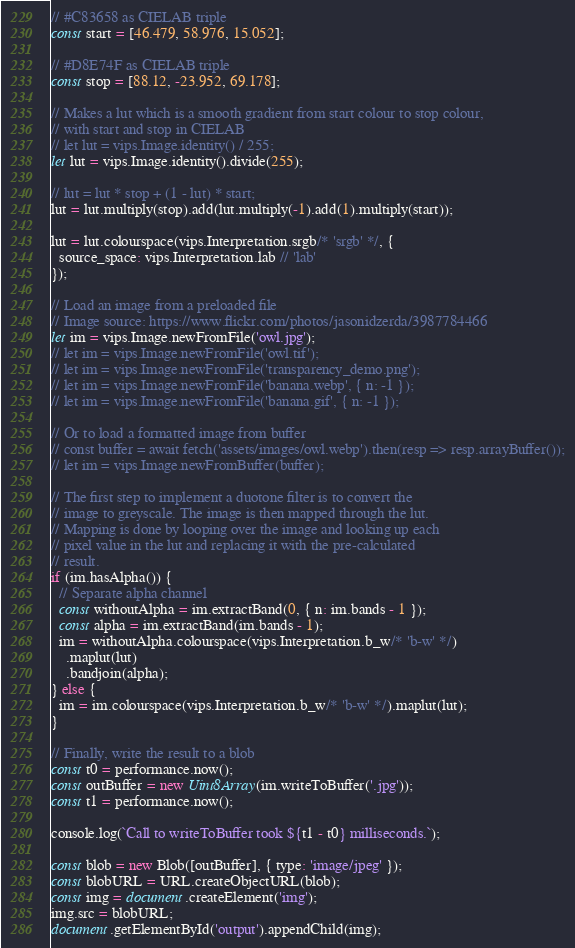<code> <loc_0><loc_0><loc_500><loc_500><_JavaScript_>// #C83658 as CIELAB triple
const start = [46.479, 58.976, 15.052];

// #D8E74F as CIELAB triple
const stop = [88.12, -23.952, 69.178];

// Makes a lut which is a smooth gradient from start colour to stop colour,
// with start and stop in CIELAB
// let lut = vips.Image.identity() / 255;
let lut = vips.Image.identity().divide(255);

// lut = lut * stop + (1 - lut) * start;
lut = lut.multiply(stop).add(lut.multiply(-1).add(1).multiply(start));

lut = lut.colourspace(vips.Interpretation.srgb/* 'srgb' */, {
  source_space: vips.Interpretation.lab // 'lab'
});

// Load an image from a preloaded file
// Image source: https://www.flickr.com/photos/jasonidzerda/3987784466
let im = vips.Image.newFromFile('owl.jpg');
// let im = vips.Image.newFromFile('owl.tif');
// let im = vips.Image.newFromFile('transparency_demo.png');
// let im = vips.Image.newFromFile('banana.webp', { n: -1 });
// let im = vips.Image.newFromFile('banana.gif', { n: -1 });

// Or to load a formatted image from buffer
// const buffer = await fetch('assets/images/owl.webp').then(resp => resp.arrayBuffer());
// let im = vips.Image.newFromBuffer(buffer);

// The first step to implement a duotone filter is to convert the
// image to greyscale. The image is then mapped through the lut.
// Mapping is done by looping over the image and looking up each
// pixel value in the lut and replacing it with the pre-calculated
// result.
if (im.hasAlpha()) {
  // Separate alpha channel
  const withoutAlpha = im.extractBand(0, { n: im.bands - 1 });
  const alpha = im.extractBand(im.bands - 1);
  im = withoutAlpha.colourspace(vips.Interpretation.b_w/* 'b-w' */)
    .maplut(lut)
    .bandjoin(alpha);
} else {
  im = im.colourspace(vips.Interpretation.b_w/* 'b-w' */).maplut(lut);
}

// Finally, write the result to a blob
const t0 = performance.now();
const outBuffer = new Uint8Array(im.writeToBuffer('.jpg'));
const t1 = performance.now();

console.log(`Call to writeToBuffer took ${t1 - t0} milliseconds.`);

const blob = new Blob([outBuffer], { type: 'image/jpeg' });
const blobURL = URL.createObjectURL(blob);
const img = document.createElement('img');
img.src = blobURL;
document.getElementById('output').appendChild(img);
</code> 